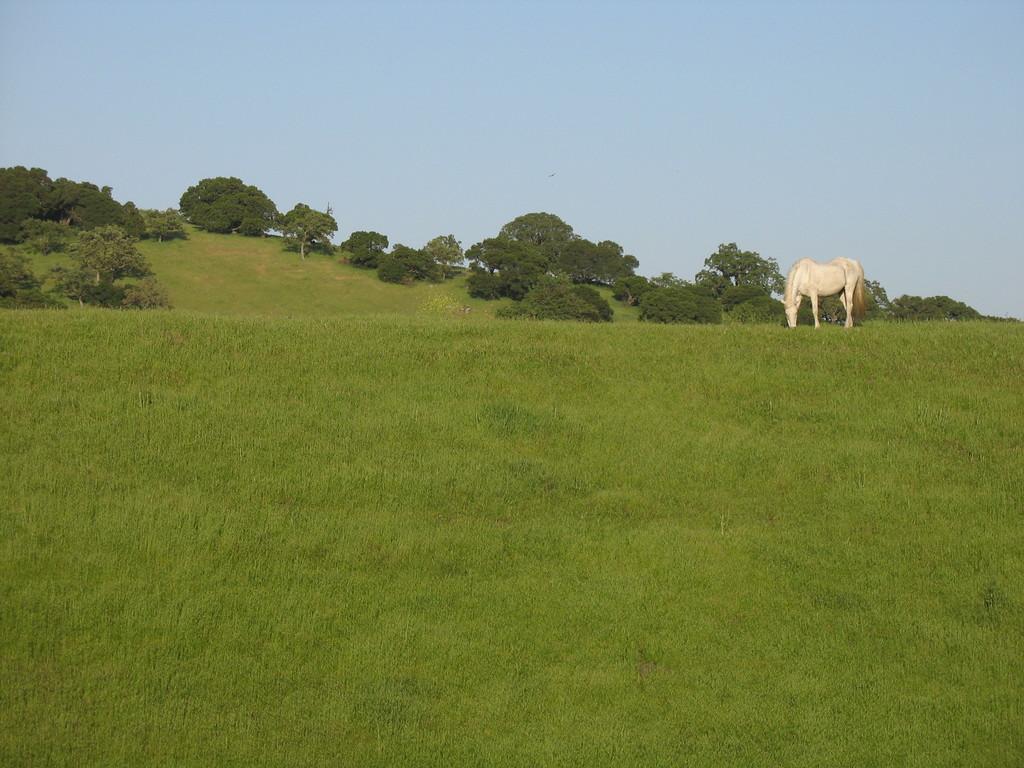In one or two sentences, can you explain what this image depicts? In this image I can see an open grass ground. On the right side of this image I can see a white colour horse is standing. In the background I can see number of trees and the sky. 